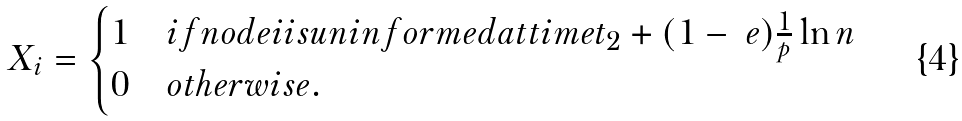<formula> <loc_0><loc_0><loc_500><loc_500>X _ { i } = \begin{cases} 1 & i f n o d e i i s u n i n f o r m e d a t t i m e t _ { 2 } + ( 1 - \ e ) \frac { 1 } { p } \ln n \\ 0 & o t h e r w i s e . \end{cases}</formula> 